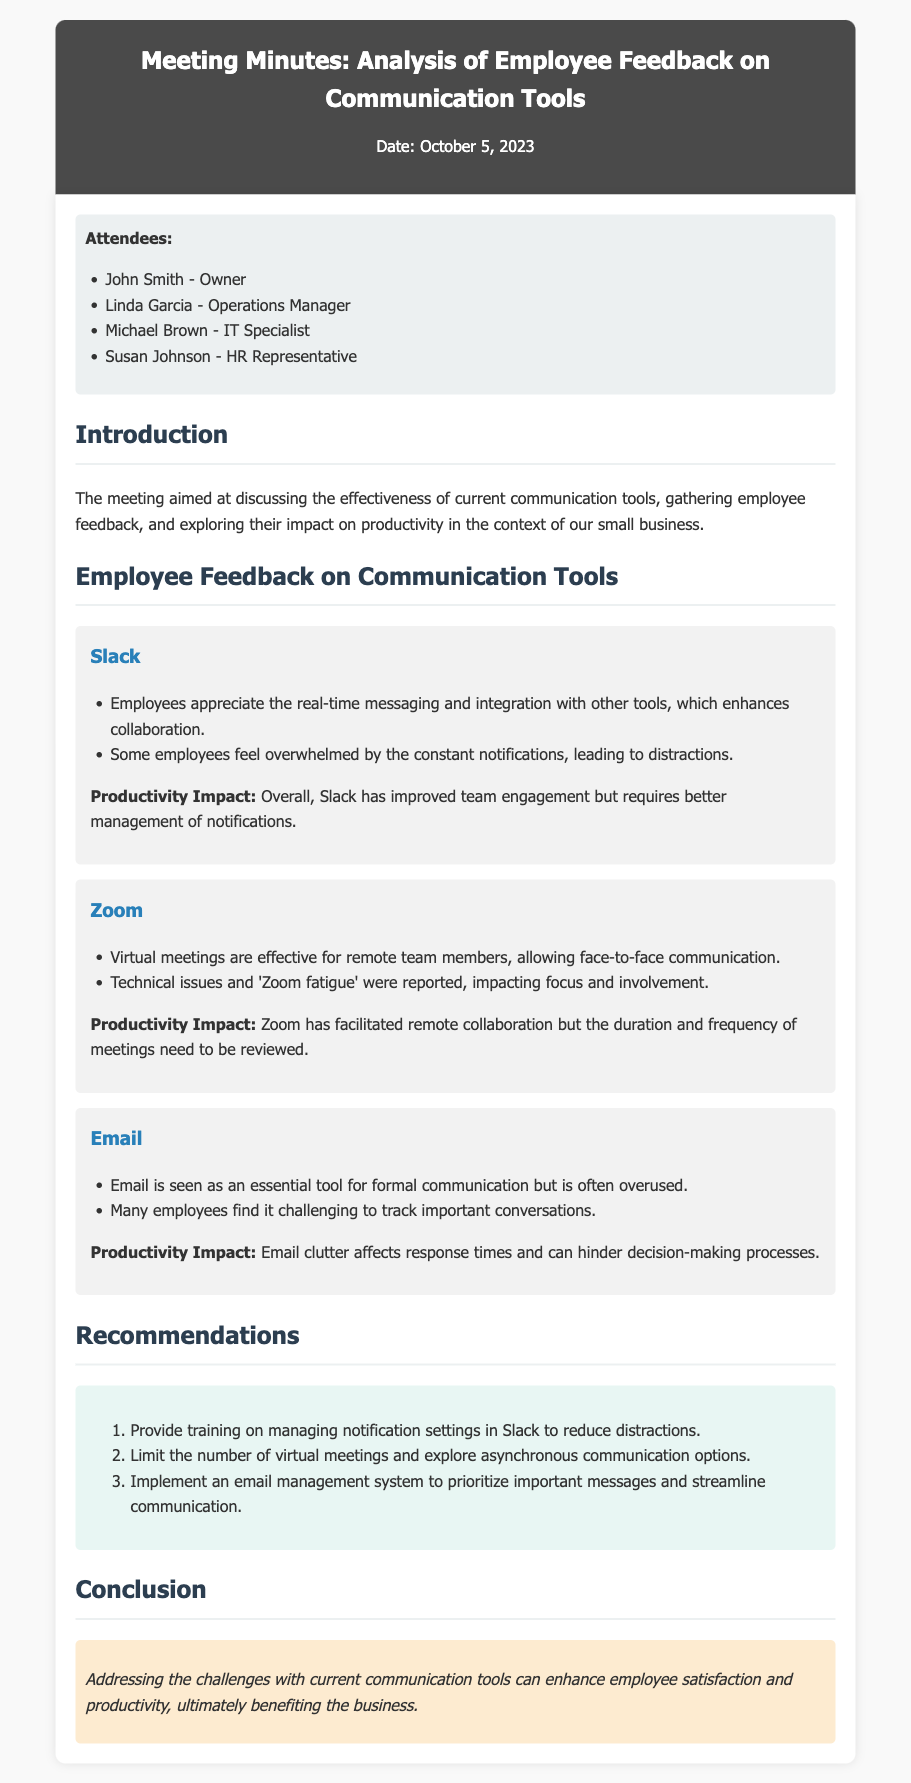what is the date of the meeting? The date of the meeting is explicitly mentioned at the beginning of the document.
Answer: October 5, 2023 who is the operations manager? The role of operations manager is assigned to Linda Garcia, as listed in the attendees section.
Answer: Linda Garcia what communication tool did employees appreciate for real-time messaging? This information is provided in the feedback section regarding Slack.
Answer: Slack what was reported as a negative aspect of Zoom meetings? The feedback on Zoom mentions technical issues and 'Zoom fatigue' as negative aspects.
Answer: Technical issues how many recommendations are provided in the document? The number of recommendations is stated in the recommendations section.
Answer: Three which tool is seen as essential for formal communication? The document specifies that Email is regarded as essential for formal communication.
Answer: Email what is the conclusion about addressing challenges with communication tools? The conclusion summarizes the benefits of addressing challenges with communication tools specifically.
Answer: Enhance employee satisfaction and productivity what does the document suggest for managing notifications in Slack? A specific recommendation in the document addresses this issue directly.
Answer: Provide training on managing notification settings in Slack 